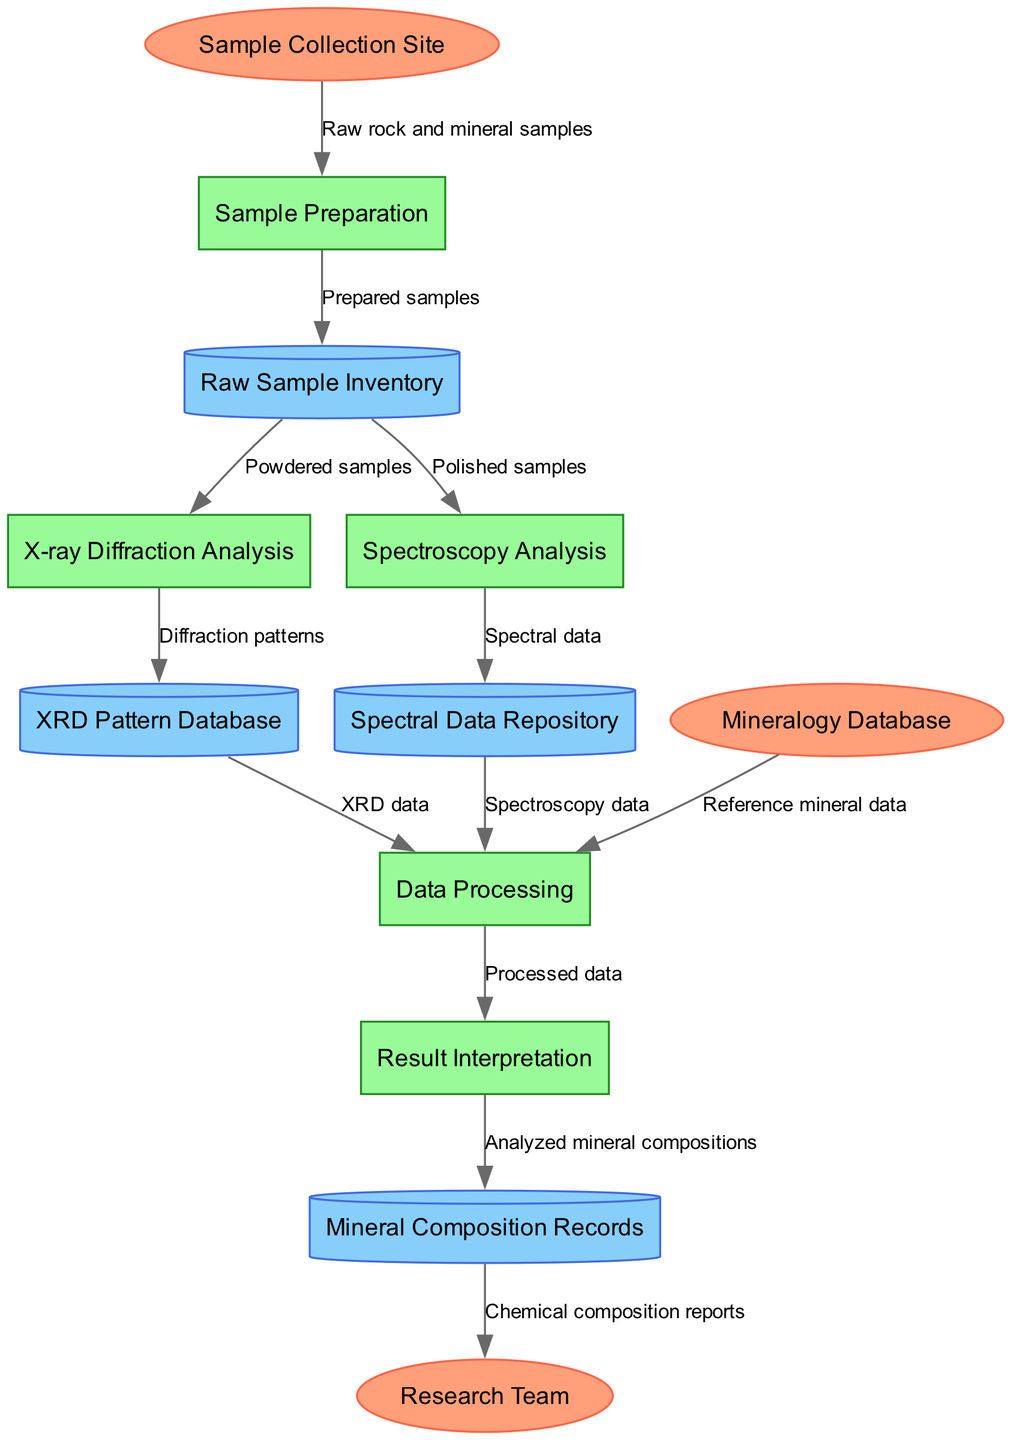What is the first step in the data flow? The first step is "Sample Preparation," which is connected to "Sample Collection Site" through the data flow of raw rock and mineral samples.
Answer: Sample Preparation How many processes are depicted in the diagram? The diagram shows a total of five processes: Sample Preparation, X-ray Diffraction Analysis, Spectroscopy Analysis, Data Processing, and Result Interpretation.
Answer: 5 What type of data is stored in the XRD Pattern Database? The data stored in the XRD Pattern Database consists of "Diffraction patterns," which are generated from the X-ray Diffraction Analysis process.
Answer: Diffraction patterns Which entity provides reference mineral data for data processing? The "Mineralogy Database" provides reference mineral data that is needed for the Data Processing phase.
Answer: Mineralogy Database What is the end result delivered to the Research Team? The end result delivered to the Research Team is "Chemical composition reports," which are based on the analyzed mineral compositions from the Result Interpretation step.
Answer: Chemical composition reports How are polished samples utilized in the workflow? Polished samples are directed to the Spectroscopy Analysis process, where they are analyzed to produce spectral data.
Answer: Spectroscopy Analysis What is the flow from Data Processing to Result Interpretation? The flow from Data Processing to Result Interpretation consists of "Processed data" that has been analyzed and is ready for interpretation regarding mineral composition.
Answer: Processed data What type of diagram is this, and what does it illustrate? This is a Data Flow Diagram, which illustrates the flow of data and processes associated with the analytical procedures for X-ray diffraction and spectroscopy in a laboratory setting.
Answer: Data Flow Diagram 